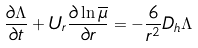Convert formula to latex. <formula><loc_0><loc_0><loc_500><loc_500>\frac { \partial \Lambda } { \partial t } + U _ { r } \frac { \partial \ln \overline { \mu } } { \partial r } = - \frac { 6 } { r ^ { 2 } } D _ { h } \Lambda</formula> 